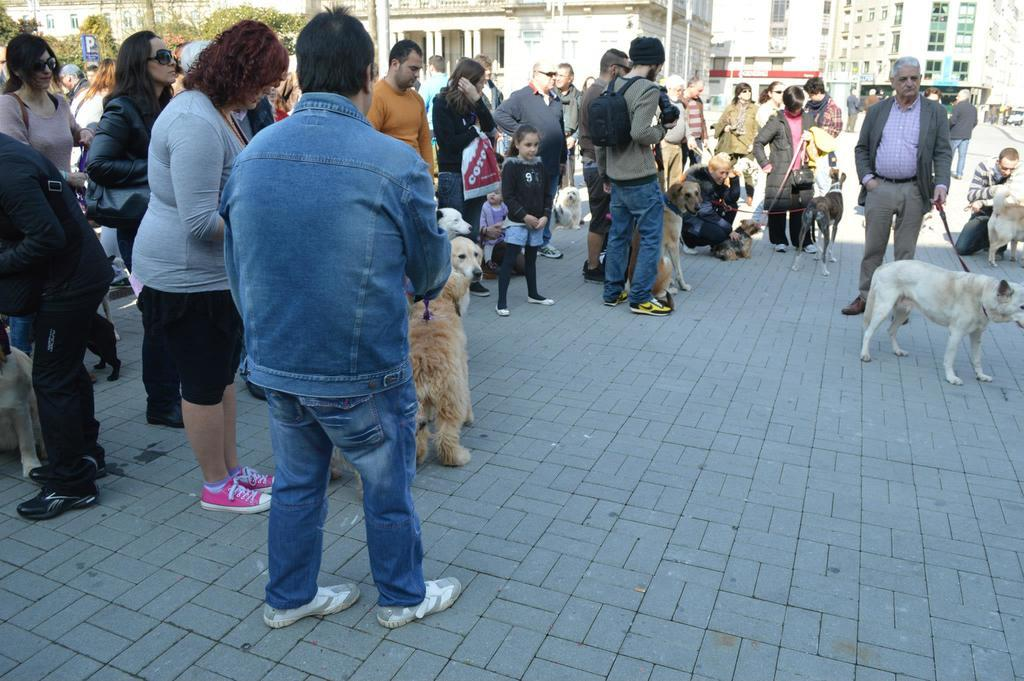How many individuals are visible in the image? There are many people in the image. Can you describe the gender distribution among the people? Both men and women are present in the image. Are there any children in the image? Yes, there are kids in the image. What are some people doing with their pets in the image? Some people are carrying dogs in the image. What can be seen in the background of the image? There are trees and buildings in the background of the image. What type of glass is being used to support the hospital in the image? There is no glass or hospital present in the image. 